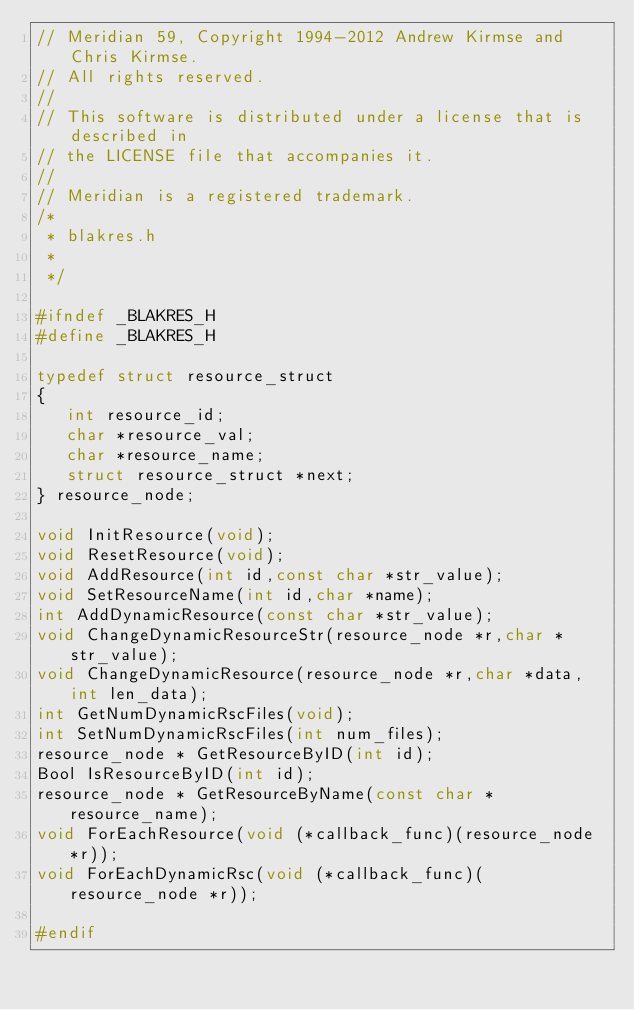Convert code to text. <code><loc_0><loc_0><loc_500><loc_500><_C_>// Meridian 59, Copyright 1994-2012 Andrew Kirmse and Chris Kirmse.
// All rights reserved.
//
// This software is distributed under a license that is described in
// the LICENSE file that accompanies it.
//
// Meridian is a registered trademark.
/* 
 * blakres.h
 *
 */

#ifndef _BLAKRES_H
#define _BLAKRES_H

typedef struct resource_struct
{
   int resource_id;
   char *resource_val;
   char *resource_name;
   struct resource_struct *next;
} resource_node;

void InitResource(void);
void ResetResource(void);
void AddResource(int id,const char *str_value);
void SetResourceName(int id,char *name);
int AddDynamicResource(const char *str_value);
void ChangeDynamicResourceStr(resource_node *r,char *str_value);
void ChangeDynamicResource(resource_node *r,char *data,int len_data);
int GetNumDynamicRscFiles(void);
int SetNumDynamicRscFiles(int num_files);
resource_node * GetResourceByID(int id);
Bool IsResourceByID(int id);
resource_node * GetResourceByName(const char *resource_name);
void ForEachResource(void (*callback_func)(resource_node *r));
void ForEachDynamicRsc(void (*callback_func)(resource_node *r));

#endif
</code> 